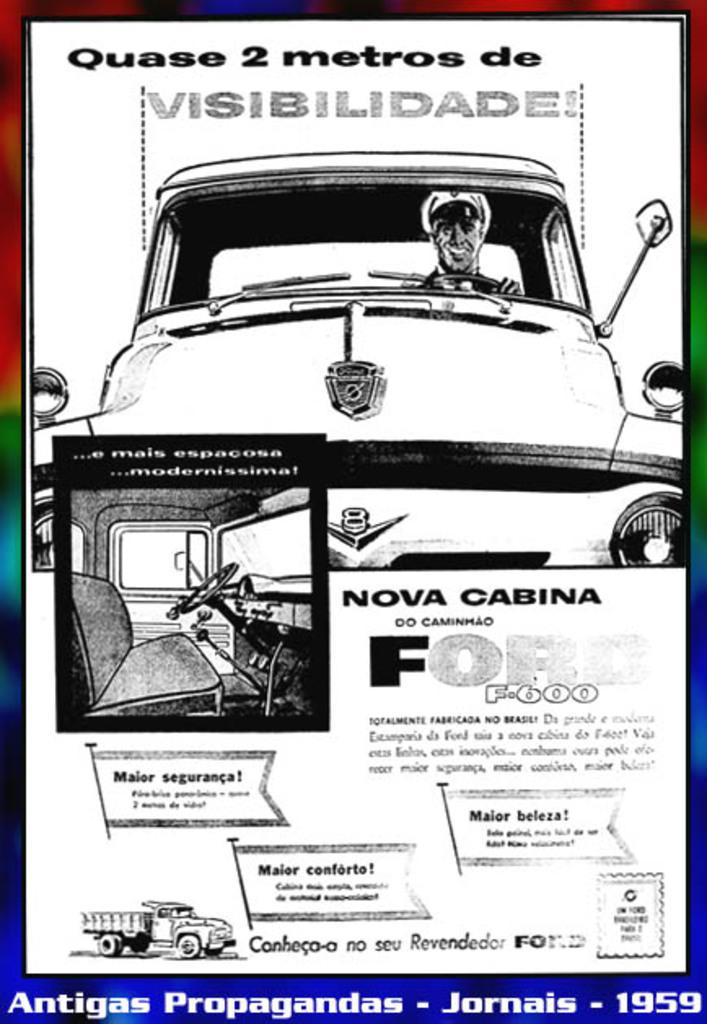Can you describe this image briefly? In this picture I can see there is a brochure and there is a person riding the car and there is a truck. There is something written on it. 